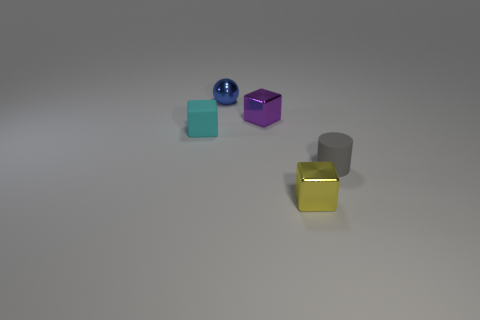Subtract all cyan blocks. How many blocks are left? 2 Add 4 large purple rubber blocks. How many objects exist? 9 Subtract all cyan blocks. How many blocks are left? 2 Subtract 1 cylinders. How many cylinders are left? 0 Subtract all blocks. How many objects are left? 2 Add 2 shiny objects. How many shiny objects are left? 5 Add 5 tiny cyan balls. How many tiny cyan balls exist? 5 Subtract 1 blue spheres. How many objects are left? 4 Subtract all purple blocks. Subtract all cyan cylinders. How many blocks are left? 2 Subtract all gray matte cylinders. Subtract all tiny blue objects. How many objects are left? 3 